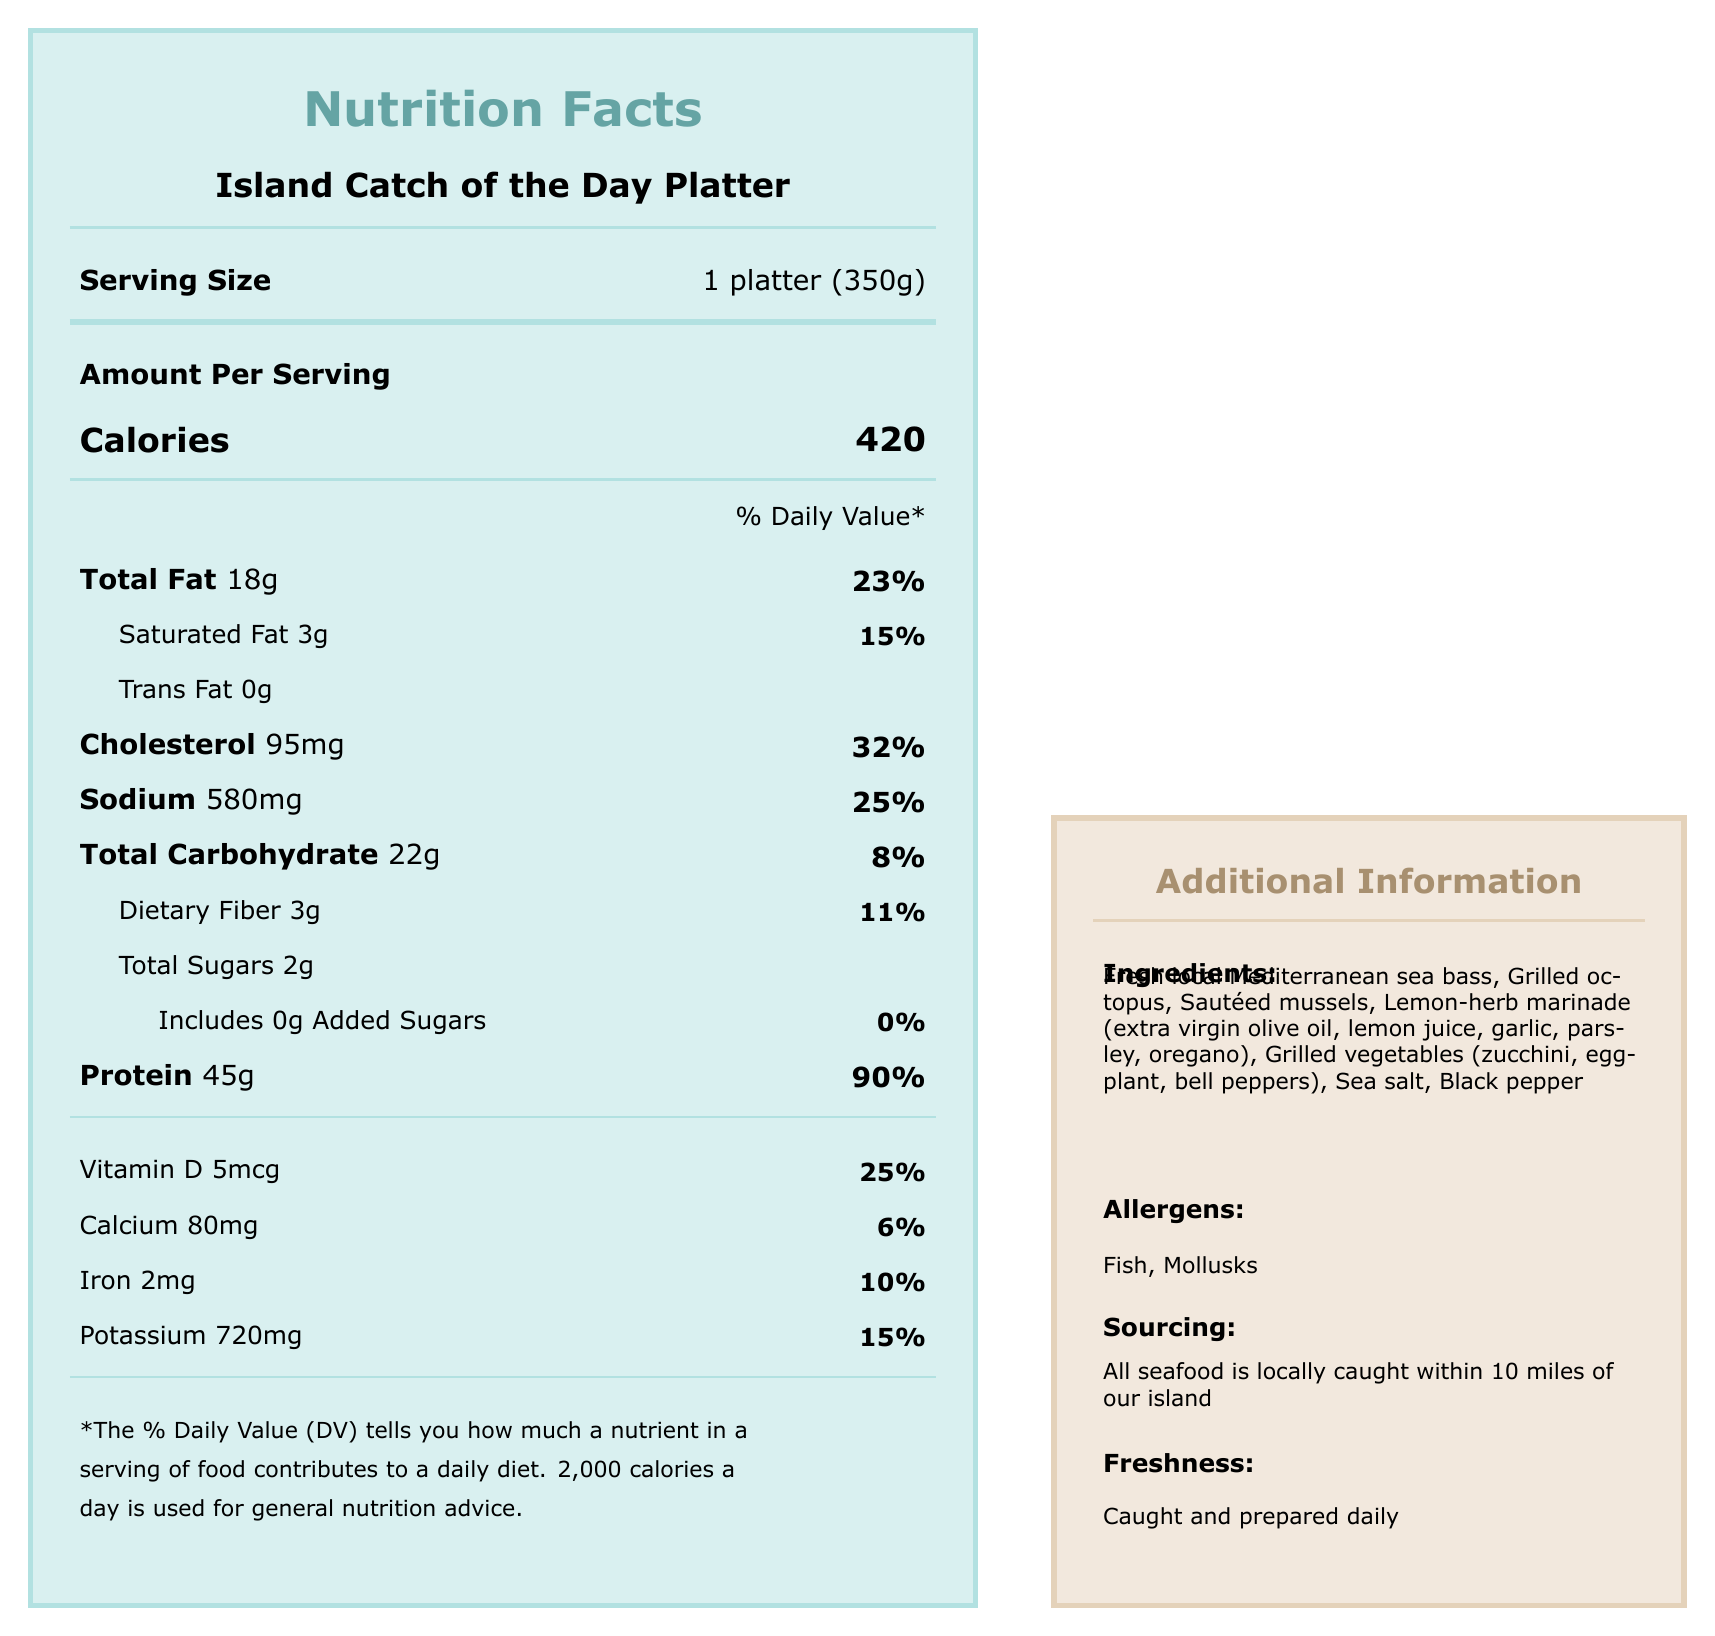who would likely ask for the nutritional information of the Island Catch of the Day Platter? Guests with specific dietary needs or preferences often look for nutritional information to assess if the dish fits their diet.
Answer: Guests with dietary requirements or health-conscious guests how many calories are in one serving of the Island Catch of the Day Platter? The document specifies that one serving of the platter contains 420 calories.
Answer: 420 calories what is the serving size for the Island Catch of the Day Platter? The document indicates that the serving size is one platter weighing 350 grams.
Answer: 1 platter (350g) what percentage of the daily value does the total fat content of the platter represent? The document lists that the total fat content of the platter is 18 grams, which is 23% of the daily value.
Answer: 23% how much protein is present in one serving of the platter? The document states that one serving of the platter has 45 grams of protein.
Answer: 45g which ingredient is not included in the platter: sea bass, salmon, or mussels? A. Sea bass B. Salmon C. Mussels The ingredients list includes sea bass and mussels but does not mention salmon.
Answer: B. Salmon how much dietary fiber is in the platter, and what is its daily value percentage? The document indicates that the platter contains 3 grams of dietary fiber, which is 11% of the daily value.
Answer: 3g, 11% What are the main allergens in the Island Catch of the Day Platter? The document lists fish and mollusks as the main allergens in the platter.
Answer: Fish, Mollusks what are the added sugars in the platter? The document states that the platter contains 0 grams of added sugars.
Answer: 0g is this meal suitable for someone on a low-sodium diet? The document indicates that the platter contains 580mg of sodium, which is 25% of the daily value, making it relatively high in sodium.
Answer: No what is the main source of protein in the platter? The fresh local Mediterranean sea bass, as listed in the ingredients, is the main source of protein in the platter.
Answer: Fresh local Mediterranean sea bass what is the percentage of the daily value for vitamin D in the platter? The document states that the platter contains 5mcg of vitamin D, which is 25% of the daily value.
Answer: 25% which of the following is an ingredient in the lemon-herb marinade? A. Basil B. Ginger C. Oregano D. Cilantro The document lists extra virgin olive oil, lemon juice, garlic, parsley, and oregano as ingredients in the lemon-herb marinade.
Answer: C. Oregano is all seafood in the platter locally sourced? The document states that all seafood is locally caught within 10 miles of the island.
Answer: Yes describe the additional information provided about the Island Catch of the Day Platter. The additional information indicates that all seafood is locally caught, supports sustainable fishing practices, is prepared daily, and is cooked with minimal oil to preserve natural flavors and nutrients.
Answer: The platter features local, sustainably caught seafood cooked and prepared daily to ensure freshness. what is the recommended daily calorie intake according to the document? The document suggests that 2,000 calories are used for general nutrition advice.
Answer: 2,000 calories how much iron is in the platter, and what is its daily value percentage? The document shows that the platter contains 2mg of iron, which is 10% of the daily value.
Answer: 2mg, 10% what makes the Island Catch of the Day Platter suitable for health-conscious guests? A. High protein B. Locally sourced C. Minimal oil usage D. All of the above The platter is high in protein, locally sourced, and cooked with minimal oil, making it suitable for health-conscious guests.
Answer: D. All of the above explain the sustainability practices mentioned in the additional information. The additional information highlights a commitment to sustainable fishing practices to ensure the protection of the marine ecosystem.
Answer: The platter supports sustainable fishing practices to protect the marine ecosystem. 